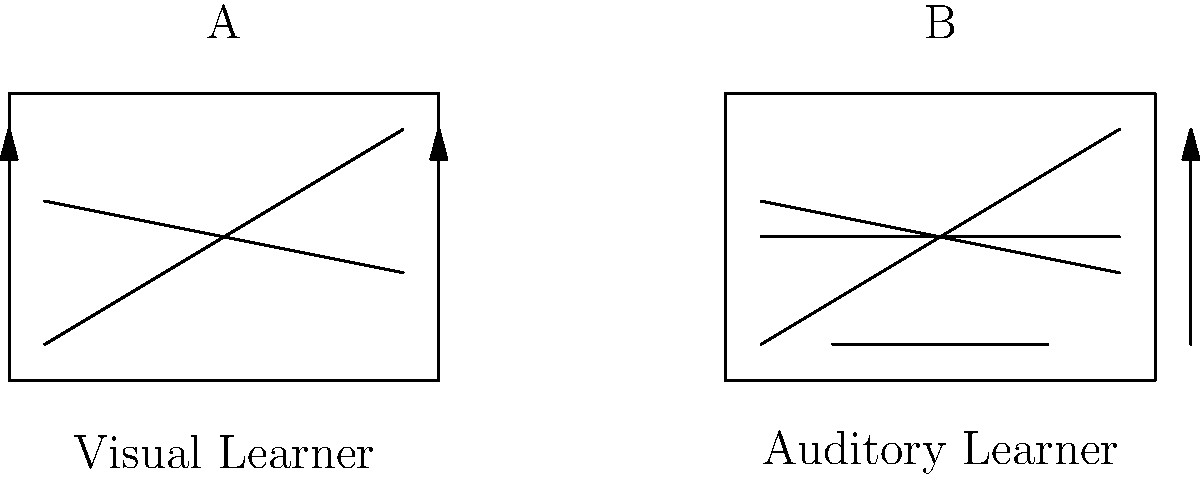Which wireframe layout (A or B) would be most suitable for a language learning software interface designed for visual learners? To determine the most suitable wireframe layout for visual learners, let's analyze both options:

1. Wireframe A (left):
   - Contains multiple horizontal lines, suggesting a list or text-based layout
   - Includes vertical arrows, indicating potential for image or video content
   - Overall structure implies a more visual-oriented design

2. Wireframe B (right):
   - Has fewer horizontal lines, suggesting less text-based content
   - Includes a central horizontal line, possibly representing an audio player
   - The arrow on the right might indicate audio playback controls

3. Visual learners:
   - Prefer information presented in visual formats (images, diagrams, videos)
   - Benefit from seeing written information and visual cues
   - Learn best when content is organized spatially

4. Comparing the wireframes:
   - Wireframe A offers more potential for visual content organization
   - The multiple lines in A can represent text, images, or video thumbnails
   - The arrows in A suggest the possibility of interactive visual elements

5. Conclusion:
   Wireframe A is more suitable for visual learners as it provides a layout that can accommodate more visual elements and spatial organization of information, which aligns better with visual learning preferences.
Answer: A 